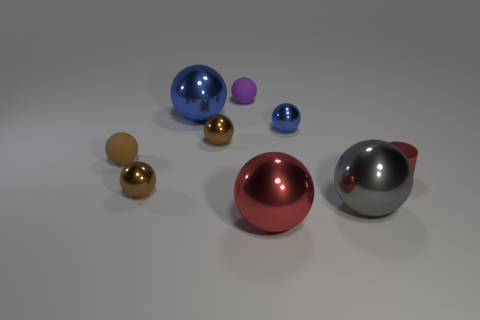What number of balls are either tiny brown things or brown rubber things?
Provide a succinct answer. 3. Is there a small gray object that has the same shape as the tiny brown matte thing?
Your response must be concise. No. What number of other things are the same color as the cylinder?
Offer a terse response. 1. Is the number of purple rubber spheres to the left of the small purple rubber object less than the number of matte spheres?
Your answer should be very brief. Yes. How many small metallic spheres are there?
Your answer should be very brief. 3. How many tiny purple things have the same material as the large red ball?
Offer a terse response. 0. What number of objects are brown things that are behind the cylinder or large metallic objects?
Your answer should be compact. 5. Are there fewer tiny things that are right of the large red metallic thing than large metal objects right of the gray object?
Ensure brevity in your answer.  No. Are there any big blue objects in front of the brown rubber ball?
Ensure brevity in your answer.  No. What number of things are shiny things that are in front of the tiny red metal object or big balls behind the gray ball?
Provide a succinct answer. 4. 